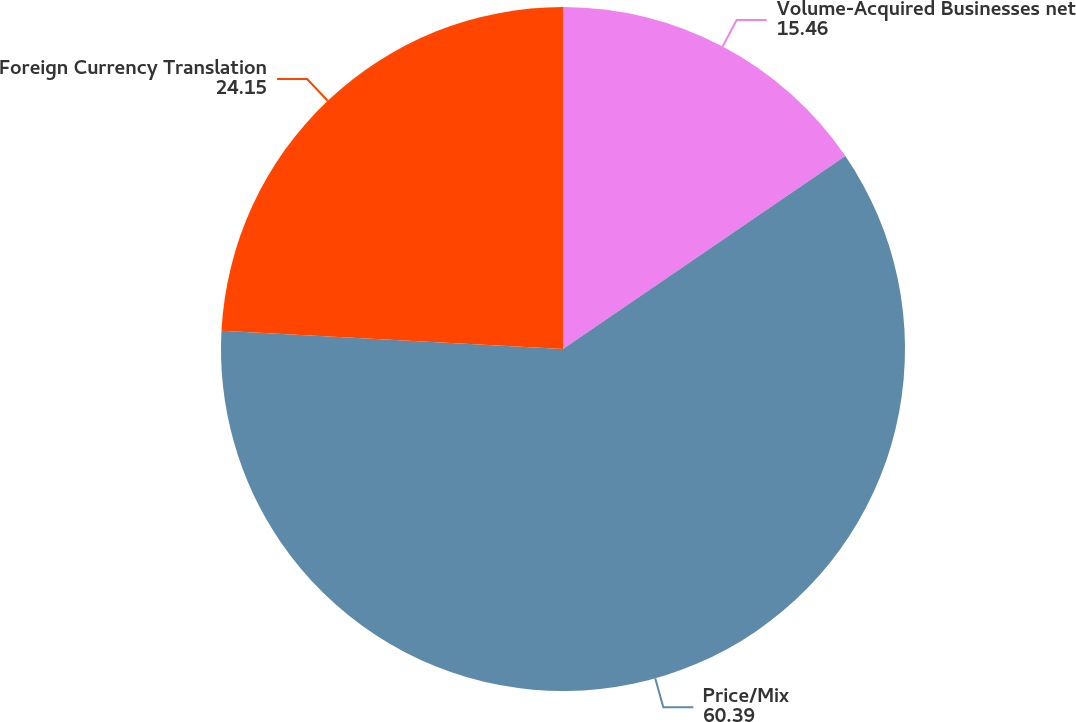Convert chart. <chart><loc_0><loc_0><loc_500><loc_500><pie_chart><fcel>Volume-Acquired Businesses net<fcel>Price/Mix<fcel>Foreign Currency Translation<nl><fcel>15.46%<fcel>60.39%<fcel>24.15%<nl></chart> 